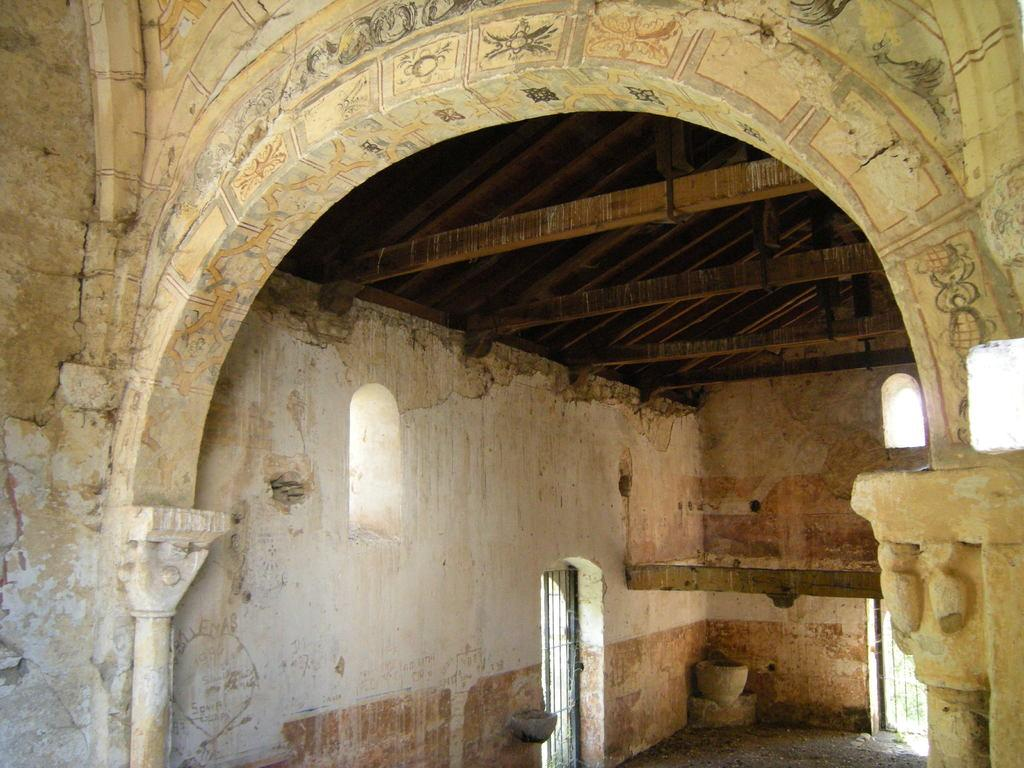What type of structure can be seen in the image? There is an arch in the image. What type of space is depicted in the image? There is a room in the image. What type of cooking appliance is visible in the image? There is a grill in the image. What allows natural light to enter the room in the image? There are windows in the image. What type of material is used for the bars in the image? There are wooden bars in the image. What surface is visible beneath the objects in the image? There is a floor in the image. What type of instrument is being played by the geese in the image? There are no geese or instruments present in the image. 